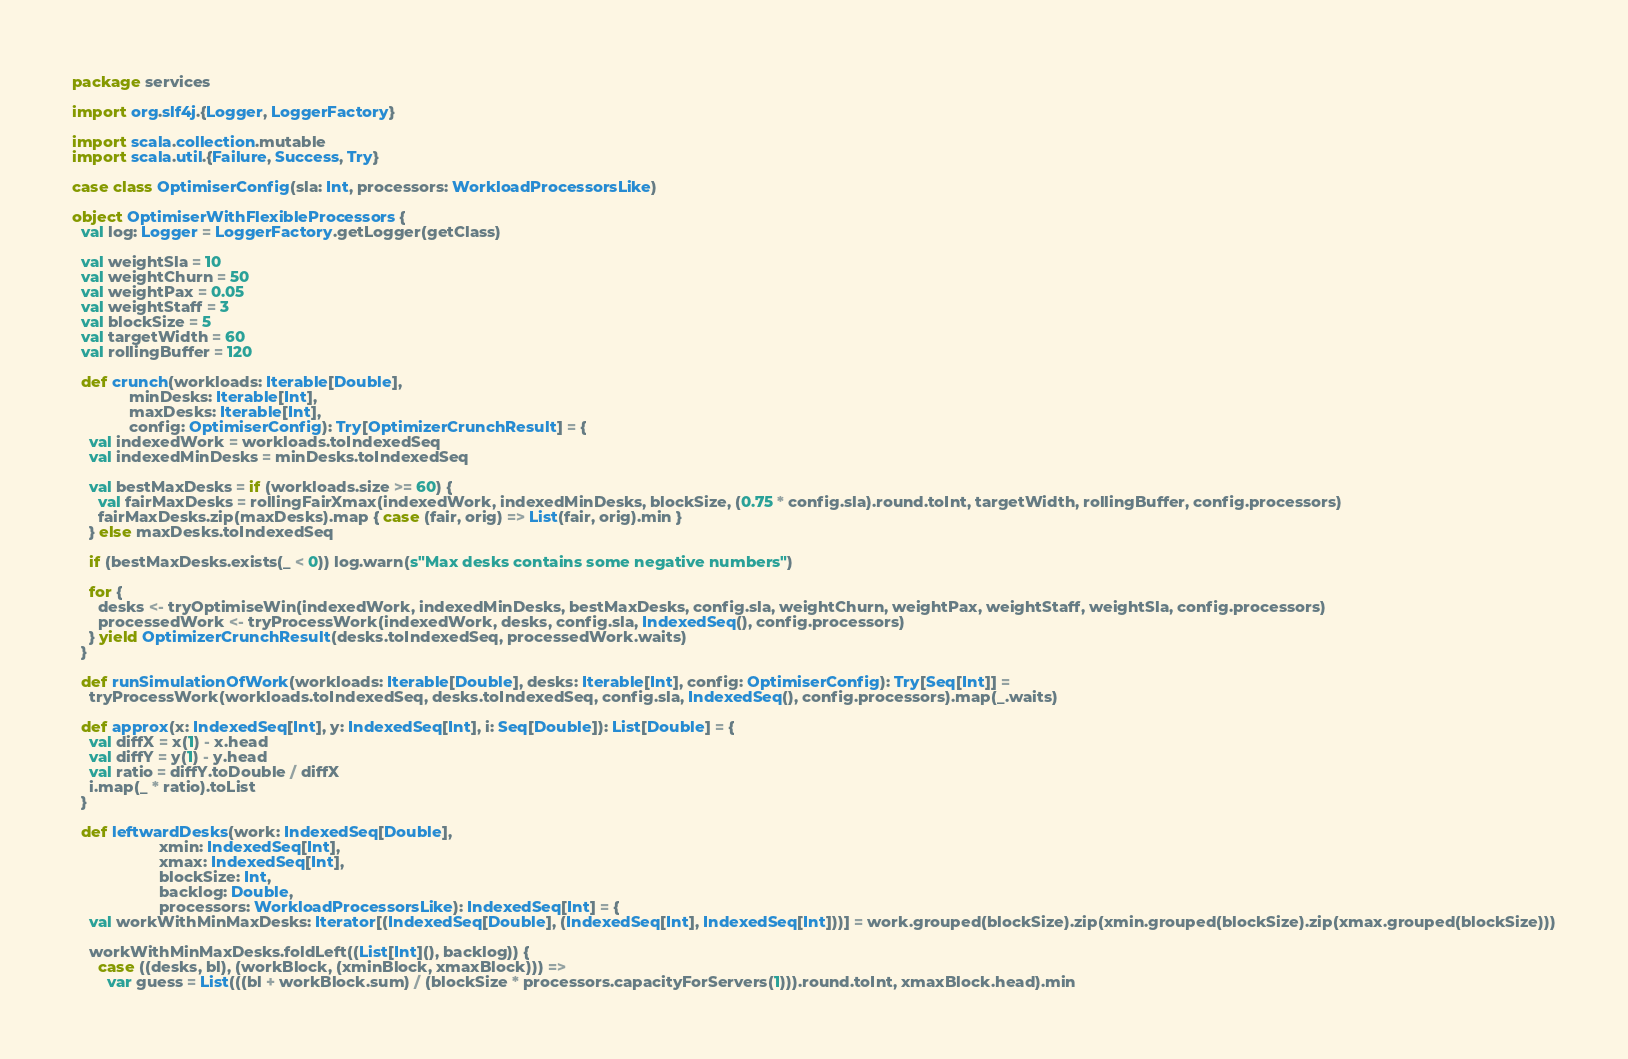<code> <loc_0><loc_0><loc_500><loc_500><_Scala_>package services

import org.slf4j.{Logger, LoggerFactory}

import scala.collection.mutable
import scala.util.{Failure, Success, Try}

case class OptimiserConfig(sla: Int, processors: WorkloadProcessorsLike)

object OptimiserWithFlexibleProcessors {
  val log: Logger = LoggerFactory.getLogger(getClass)

  val weightSla = 10
  val weightChurn = 50
  val weightPax = 0.05
  val weightStaff = 3
  val blockSize = 5
  val targetWidth = 60
  val rollingBuffer = 120

  def crunch(workloads: Iterable[Double],
             minDesks: Iterable[Int],
             maxDesks: Iterable[Int],
             config: OptimiserConfig): Try[OptimizerCrunchResult] = {
    val indexedWork = workloads.toIndexedSeq
    val indexedMinDesks = minDesks.toIndexedSeq

    val bestMaxDesks = if (workloads.size >= 60) {
      val fairMaxDesks = rollingFairXmax(indexedWork, indexedMinDesks, blockSize, (0.75 * config.sla).round.toInt, targetWidth, rollingBuffer, config.processors)
      fairMaxDesks.zip(maxDesks).map { case (fair, orig) => List(fair, orig).min }
    } else maxDesks.toIndexedSeq

    if (bestMaxDesks.exists(_ < 0)) log.warn(s"Max desks contains some negative numbers")

    for {
      desks <- tryOptimiseWin(indexedWork, indexedMinDesks, bestMaxDesks, config.sla, weightChurn, weightPax, weightStaff, weightSla, config.processors)
      processedWork <- tryProcessWork(indexedWork, desks, config.sla, IndexedSeq(), config.processors)
    } yield OptimizerCrunchResult(desks.toIndexedSeq, processedWork.waits)
  }

  def runSimulationOfWork(workloads: Iterable[Double], desks: Iterable[Int], config: OptimiserConfig): Try[Seq[Int]] =
    tryProcessWork(workloads.toIndexedSeq, desks.toIndexedSeq, config.sla, IndexedSeq(), config.processors).map(_.waits)

  def approx(x: IndexedSeq[Int], y: IndexedSeq[Int], i: Seq[Double]): List[Double] = {
    val diffX = x(1) - x.head
    val diffY = y(1) - y.head
    val ratio = diffY.toDouble / diffX
    i.map(_ * ratio).toList
  }

  def leftwardDesks(work: IndexedSeq[Double],
                    xmin: IndexedSeq[Int],
                    xmax: IndexedSeq[Int],
                    blockSize: Int,
                    backlog: Double,
                    processors: WorkloadProcessorsLike): IndexedSeq[Int] = {
    val workWithMinMaxDesks: Iterator[(IndexedSeq[Double], (IndexedSeq[Int], IndexedSeq[Int]))] = work.grouped(blockSize).zip(xmin.grouped(blockSize).zip(xmax.grouped(blockSize)))

    workWithMinMaxDesks.foldLeft((List[Int](), backlog)) {
      case ((desks, bl), (workBlock, (xminBlock, xmaxBlock))) =>
        var guess = List(((bl + workBlock.sum) / (blockSize * processors.capacityForServers(1))).round.toInt, xmaxBlock.head).min
</code> 